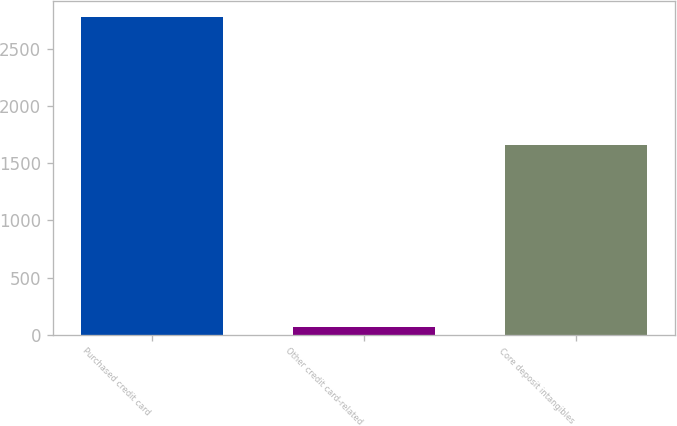Convert chart. <chart><loc_0><loc_0><loc_500><loc_500><bar_chart><fcel>Purchased credit card<fcel>Other credit card-related<fcel>Core deposit intangibles<nl><fcel>2781<fcel>65<fcel>1660<nl></chart> 